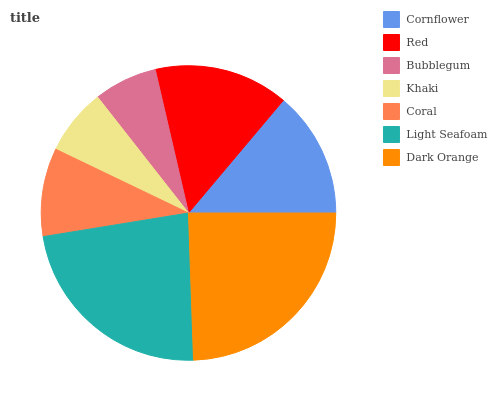Is Bubblegum the minimum?
Answer yes or no. Yes. Is Dark Orange the maximum?
Answer yes or no. Yes. Is Red the minimum?
Answer yes or no. No. Is Red the maximum?
Answer yes or no. No. Is Red greater than Cornflower?
Answer yes or no. Yes. Is Cornflower less than Red?
Answer yes or no. Yes. Is Cornflower greater than Red?
Answer yes or no. No. Is Red less than Cornflower?
Answer yes or no. No. Is Cornflower the high median?
Answer yes or no. Yes. Is Cornflower the low median?
Answer yes or no. Yes. Is Dark Orange the high median?
Answer yes or no. No. Is Coral the low median?
Answer yes or no. No. 